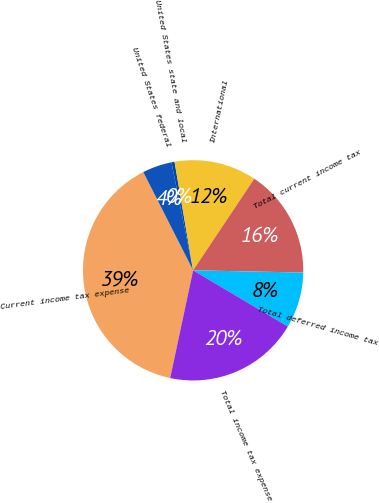Convert chart. <chart><loc_0><loc_0><loc_500><loc_500><pie_chart><fcel>Current income tax expense<fcel>United States federal<fcel>United States state and local<fcel>International<fcel>Total current income tax<fcel>Total deferred income tax<fcel>Total income tax expense<nl><fcel>39.19%<fcel>4.32%<fcel>0.45%<fcel>12.07%<fcel>15.95%<fcel>8.2%<fcel>19.82%<nl></chart> 